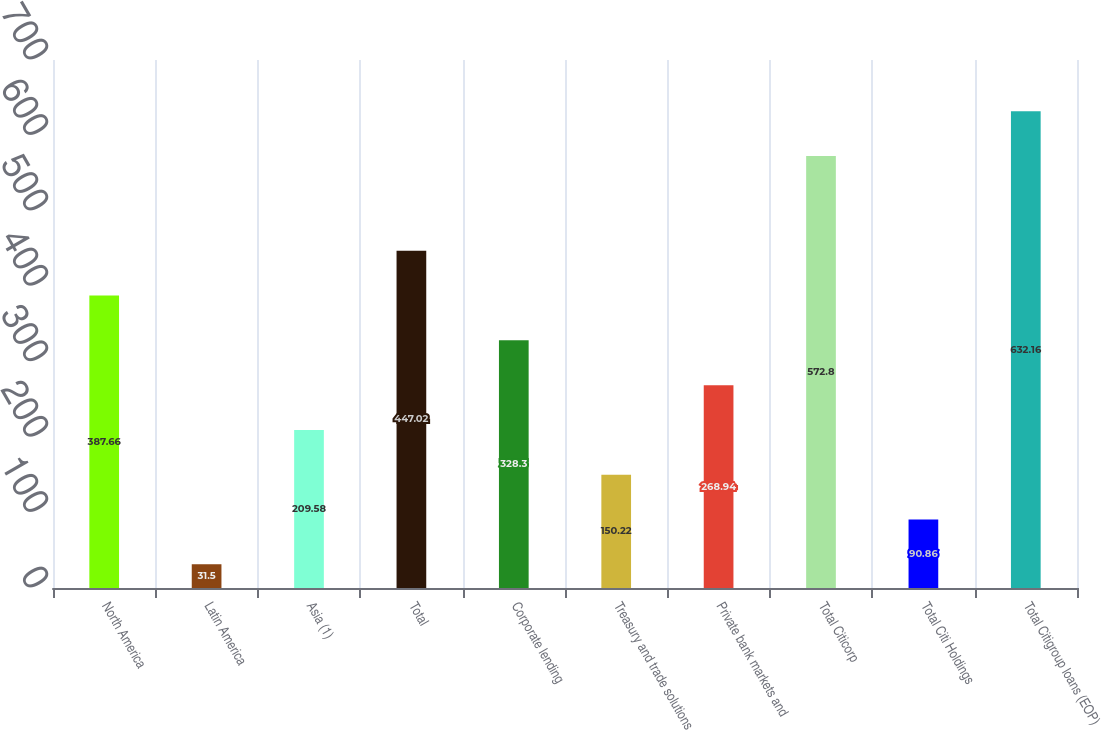<chart> <loc_0><loc_0><loc_500><loc_500><bar_chart><fcel>North America<fcel>Latin America<fcel>Asia (1)<fcel>Total<fcel>Corporate lending<fcel>Treasury and trade solutions<fcel>Private bank markets and<fcel>Total Citicorp<fcel>Total Citi Holdings<fcel>Total Citigroup loans (EOP)<nl><fcel>387.66<fcel>31.5<fcel>209.58<fcel>447.02<fcel>328.3<fcel>150.22<fcel>268.94<fcel>572.8<fcel>90.86<fcel>632.16<nl></chart> 